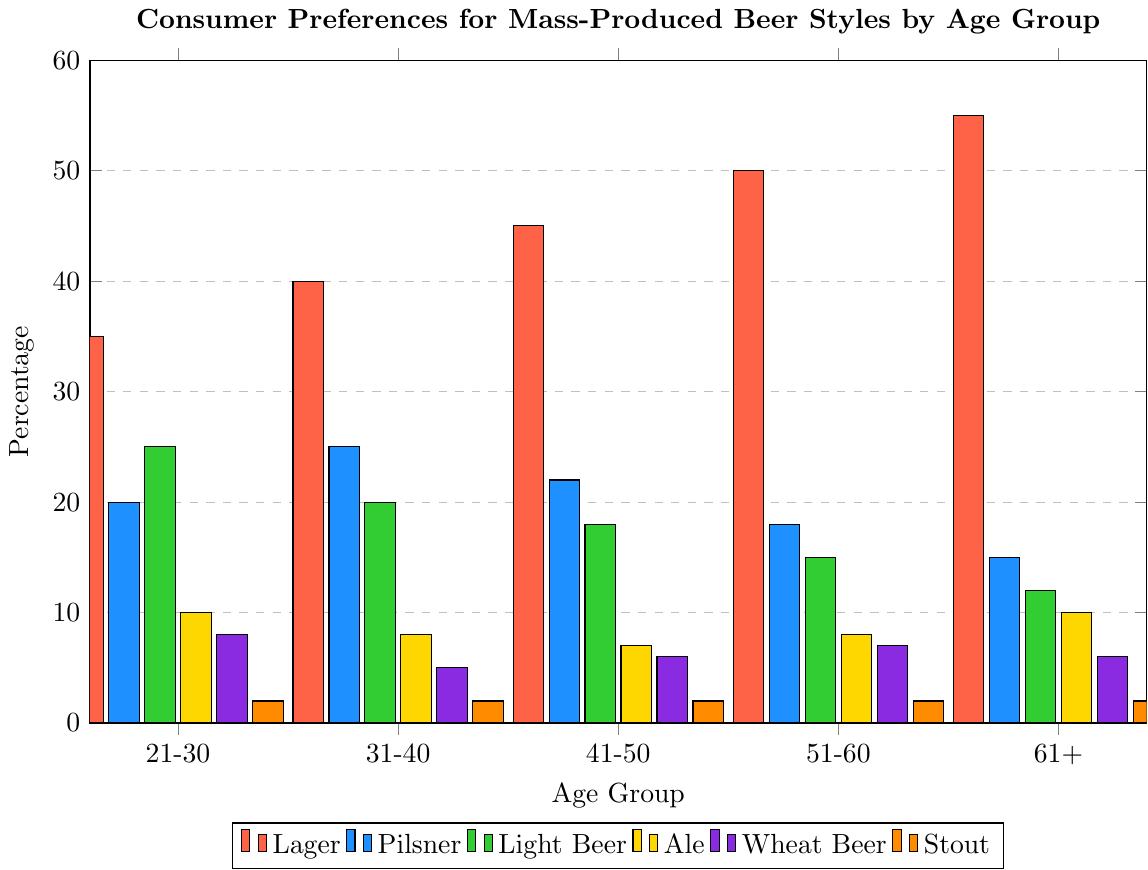Which age group prefers Lager the most? The age group with the highest percentage bar for Lager is the one that prefers it the most. From the chart, the '61+' group has the tallest red bar for Lager.
Answer: 61+ Which beer style is the least preferred across all age groups? The preferences for each beer style can be visually checked by looking for the shortest bars. The brown bars, representing Stout, are consistently the shortest for all age groups.
Answer: Stout Which age group has the most balanced preference among the different beer styles? A balanced preference would be indicated by bars of similar height. The '21-30' age group has more evenly distributed bars across different beer styles compared to other age groups.
Answer: 21-30 How much more do 51-60 year-olds prefer Lager compared to Light Beer? To find this, look at the height of the bars corresponding to Lager and Light Beer for '51-60'. Lager preference is 50%, and Light Beer preference is 15%. The difference is 50% - 15% = 35%.
Answer: 35% Which two beer styles have the smallest difference in preference for the 41-50 age group? For the '41-50' group, compare the heights of the bars. Ale and Wheat Beer have the closest values, with preferences of 7% and 6%, respectively. Subtract them: 7% - 6% = 1%.
Answer: Ale and Wheat Beer What is the combined preference for Lager and Pilsner for the 31-40 age group? Add the percentages of Lager and Pilsner for the '31-40' group. Lager has 40% and Pilsner has 25%, so the total is 40% + 25% = 65%.
Answer: 65% Is there any age group where Ale is preferred more than Light Beer? Check the heights of the bars for Ale and Light Beer in each age group. For all age groups, the Light Beer bar is taller than the Ale bar.
Answer: No Which beer style do people aged 21-30 prefer the least, and what is its percentage? For the '21-30' group, identify the shortest bar, which represents Stout, at 2%.
Answer: Stout, 2% Among the beer styles, which two are most consistently preferred across all age groups? Consistent preference means similar bar heights across age groups. Lager and Stout show this consistency; Lager bars consistently increase with age, and Stout bars are consistently short across all age groups.
Answer: Lager and Stout Do older age groups have a stronger preference for Lager compared to younger age groups? Compare the Lager bars across age groups. The height of the Lager bar increases with age, confirming that older groups prefer Lager more.
Answer: Yes 